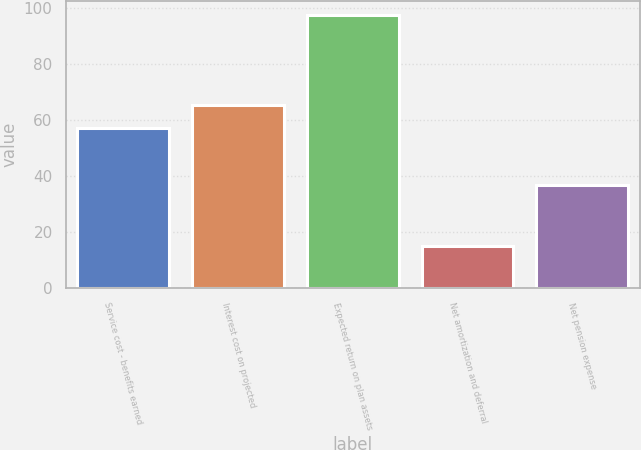<chart> <loc_0><loc_0><loc_500><loc_500><bar_chart><fcel>Service cost - benefits earned<fcel>Interest cost on projected<fcel>Expected return on plan assets<fcel>Net amortization and deferral<fcel>Net pension expense<nl><fcel>57.2<fcel>65.46<fcel>97.6<fcel>15<fcel>36.7<nl></chart> 